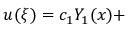Convert formula to latex. <formula><loc_0><loc_0><loc_500><loc_500>u ( \xi ) = c _ { 1 } Y _ { 1 } ( x ) +</formula> 